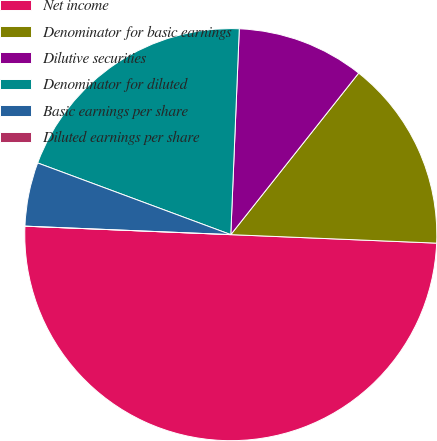<chart> <loc_0><loc_0><loc_500><loc_500><pie_chart><fcel>Net income<fcel>Denominator for basic earnings<fcel>Dilutive securities<fcel>Denominator for diluted<fcel>Basic earnings per share<fcel>Diluted earnings per share<nl><fcel>50.0%<fcel>15.0%<fcel>10.0%<fcel>20.0%<fcel>5.0%<fcel>0.0%<nl></chart> 